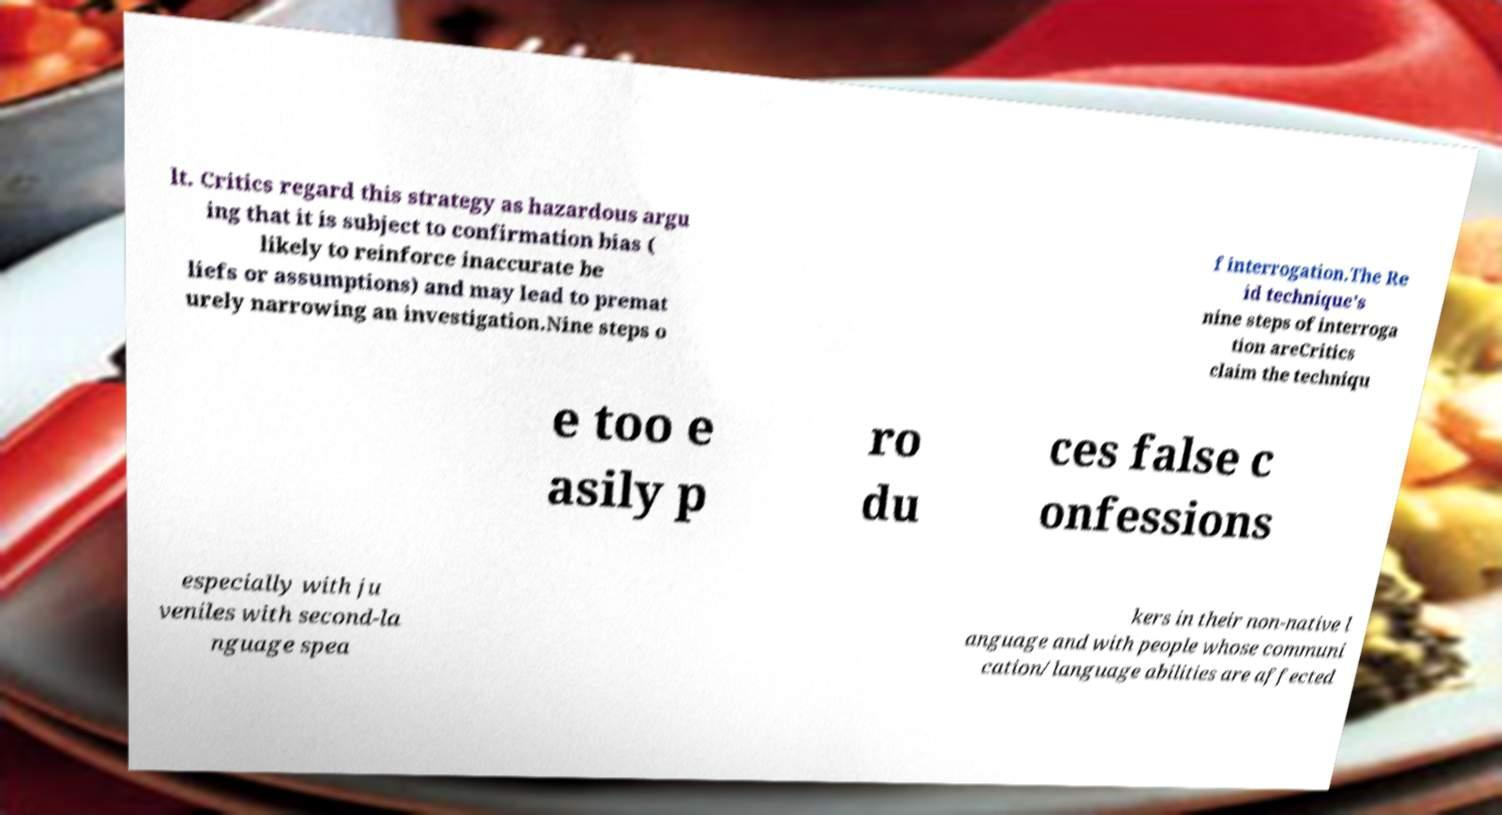Could you extract and type out the text from this image? lt. Critics regard this strategy as hazardous argu ing that it is subject to confirmation bias ( likely to reinforce inaccurate be liefs or assumptions) and may lead to premat urely narrowing an investigation.Nine steps o f interrogation.The Re id technique's nine steps of interroga tion areCritics claim the techniqu e too e asily p ro du ces false c onfessions especially with ju veniles with second-la nguage spea kers in their non-native l anguage and with people whose communi cation/language abilities are affected 